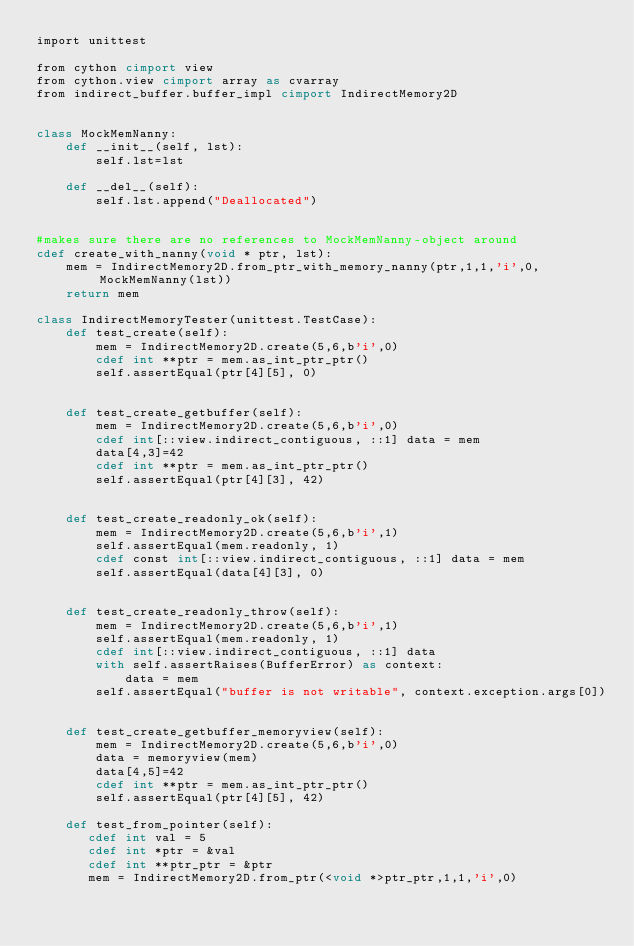Convert code to text. <code><loc_0><loc_0><loc_500><loc_500><_Cython_>import unittest

from cython cimport view
from cython.view cimport array as cvarray
from indirect_buffer.buffer_impl cimport IndirectMemory2D


class MockMemNanny:
    def __init__(self, lst):
        self.lst=lst

    def __del__(self):
        self.lst.append("Deallocated")


#makes sure there are no references to MockMemNanny-object around
cdef create_with_nanny(void * ptr, lst):
    mem = IndirectMemory2D.from_ptr_with_memory_nanny(ptr,1,1,'i',0, MockMemNanny(lst))
    return mem

class IndirectMemoryTester(unittest.TestCase): 
    def test_create(self):
        mem = IndirectMemory2D.create(5,6,b'i',0)
        cdef int **ptr = mem.as_int_ptr_ptr()
        self.assertEqual(ptr[4][5], 0)


    def test_create_getbuffer(self):
        mem = IndirectMemory2D.create(5,6,b'i',0)
        cdef int[::view.indirect_contiguous, ::1] data = mem
        data[4,3]=42
        cdef int **ptr = mem.as_int_ptr_ptr()
        self.assertEqual(ptr[4][3], 42)


    def test_create_readonly_ok(self):
        mem = IndirectMemory2D.create(5,6,b'i',1)
        self.assertEqual(mem.readonly, 1)
        cdef const int[::view.indirect_contiguous, ::1] data = mem
        self.assertEqual(data[4][3], 0)


    def test_create_readonly_throw(self):
        mem = IndirectMemory2D.create(5,6,b'i',1)
        self.assertEqual(mem.readonly, 1)
        cdef int[::view.indirect_contiguous, ::1] data
        with self.assertRaises(BufferError) as context:
            data = mem
        self.assertEqual("buffer is not writable", context.exception.args[0])


    def test_create_getbuffer_memoryview(self):
        mem = IndirectMemory2D.create(5,6,b'i',0)
        data = memoryview(mem)
        data[4,5]=42
        cdef int **ptr = mem.as_int_ptr_ptr()
        self.assertEqual(ptr[4][5], 42)

    def test_from_pointer(self):
       cdef int val = 5
       cdef int *ptr = &val
       cdef int **ptr_ptr = &ptr
       mem = IndirectMemory2D.from_ptr(<void *>ptr_ptr,1,1,'i',0)</code> 